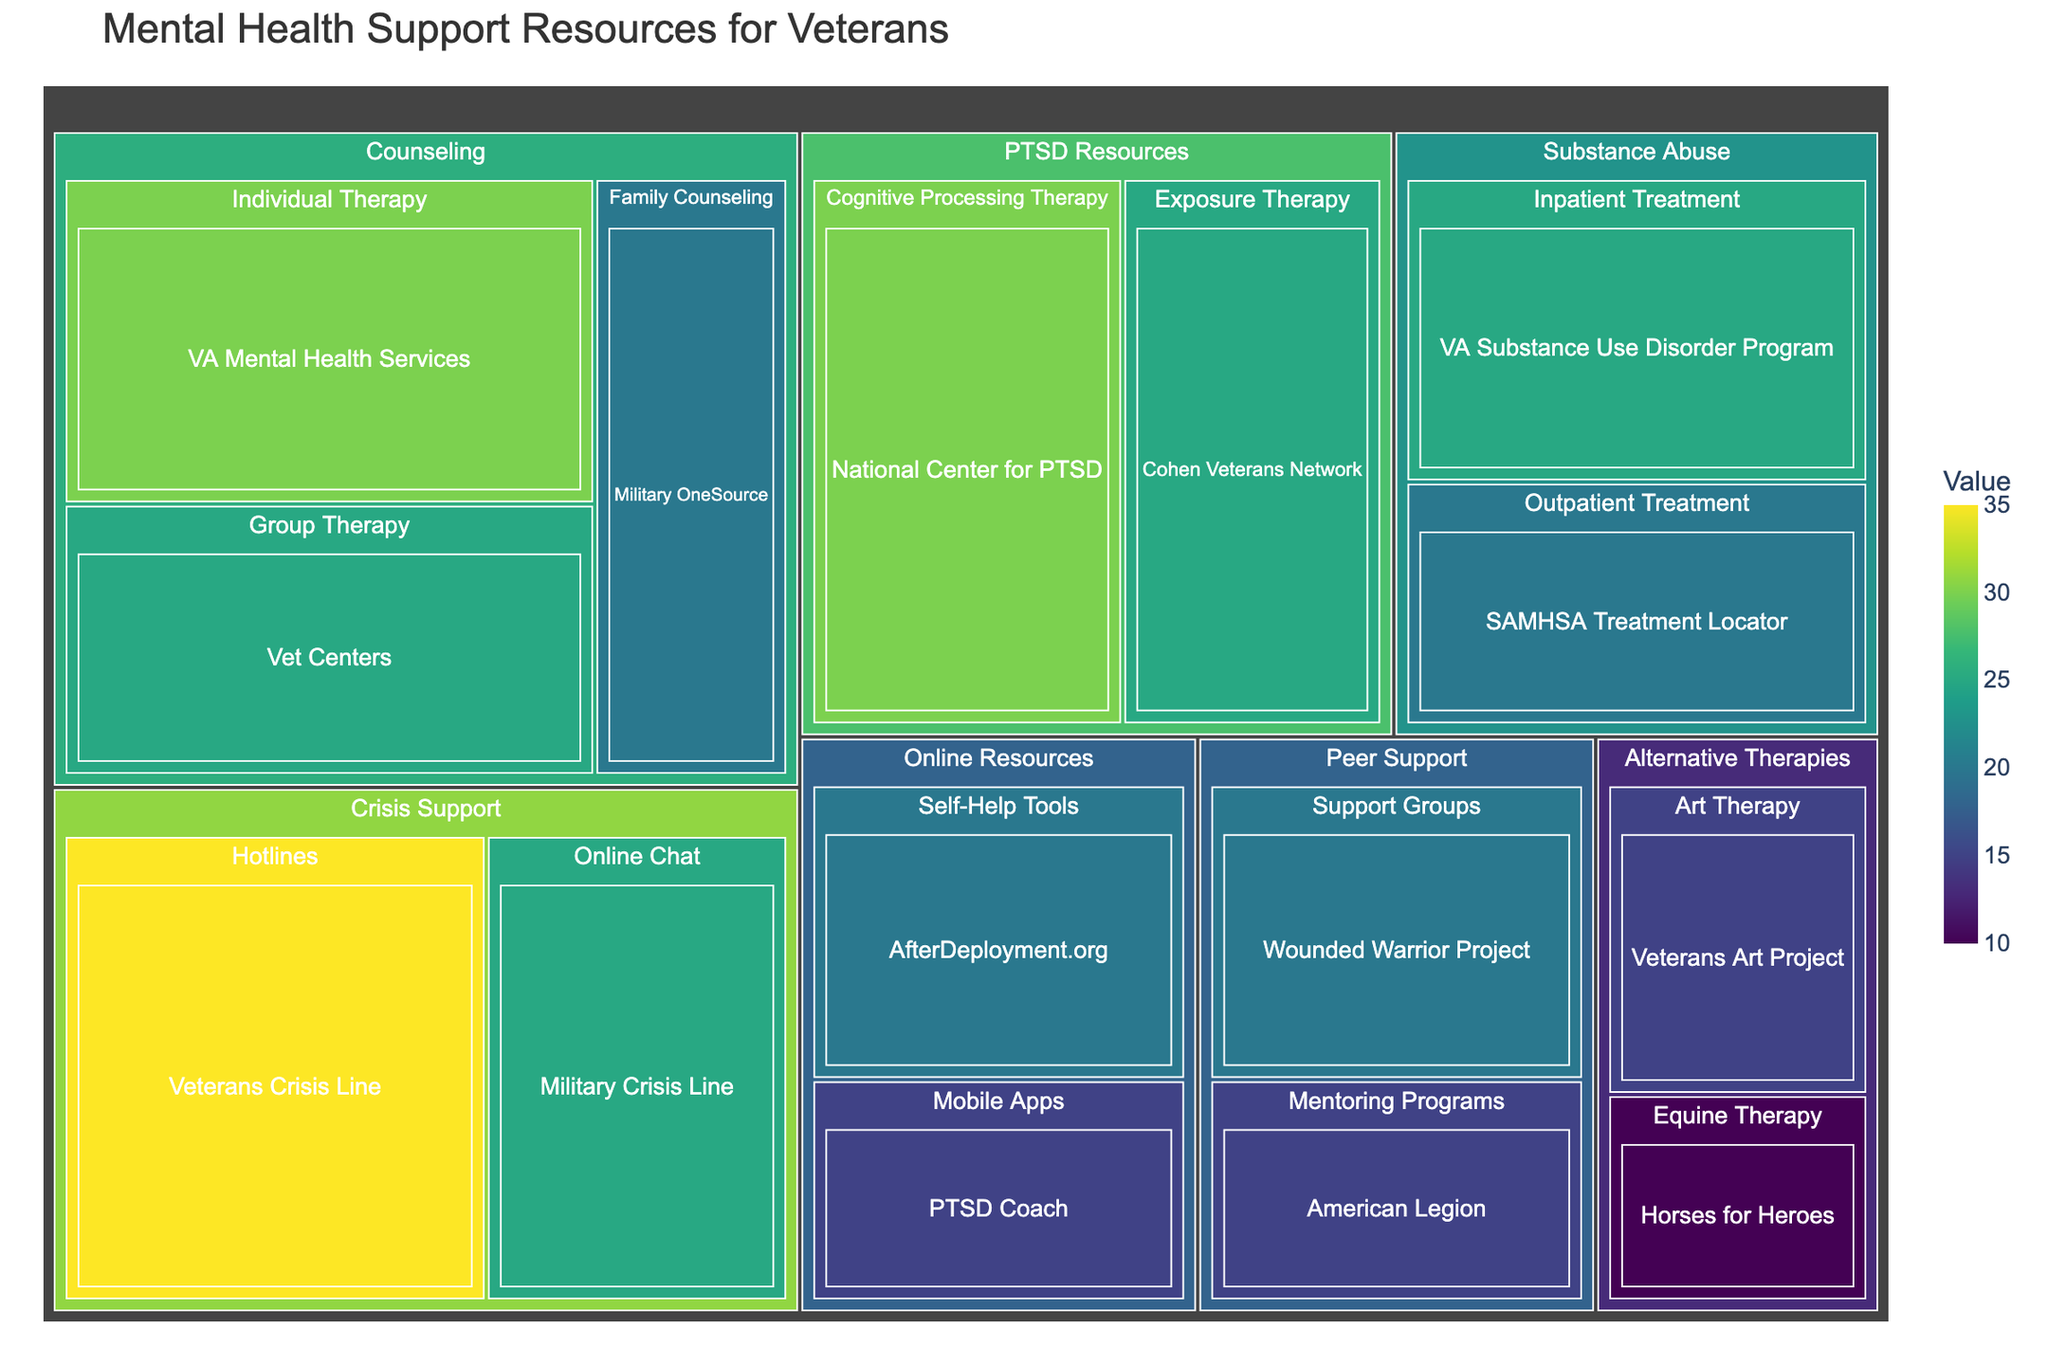what is the title of the treemap? The title can usually be found at the top of the figure. In this treemap, it is displayed prominently as a heading.
Answer: Mental Health Support Resources for Veterans Which category has the highest value? Each category is a distinct section of the treemap, distinguished by color. By comparing the values within each category, the one with the highest value can be identified. The category with the highest overall value in all its subcategories is "Counseling" with individual values adding up to 75.
Answer: Counseling What resource has the highest value within the Crisis Support category? Within each category, resources are divided into subcategories. By identifying the resource within the Crisis Support category, we see that "Veterans Crisis Line" has the highest value of 35.
Answer: Veterans Crisis Line What's the total value for Online Resources? By adding the values of "Self-Help Tools" (20) and "Mobile Apps" (15) within the Online Resources category, we get the total value. 20 + 15 = 35.
Answer: 35 Which subcategory in Substance Abuse has a higher value? By comparing the values within the subcategories of the Substance Abuse category, "Inpatient Treatment" has a value of 25, while "Outpatient Treatment" has a value of 20; hence "Inpatient Treatment" has a higher value.
Answer: Inpatient Treatment What is the average value of resources in the Peer Support category? The Peer Support category includes "Support Groups" (20) and "Mentoring Programs" (15). The average value is calculated by summing the values and dividing by the number of resources: (20 + 15) / 2 = 17.5.
Answer: 17.5 Which subcategory has the least value within the Alternative Therapies category? Looking at the values in the Alternative Therapies category, "Equine Therapy" has a value of 10, while "Art Therapy" has a value of 15. Thus, "Equine Therapy" has the least value.
Answer: Equine Therapy How does the value of VA Mental Health Services compare to the value of the Veterans Crisis Line? VA Mental Health Services has a value of 30, and the Veterans Crisis Line has a value of 35. By comparing them, we see that Veterans Crisis Line has a higher value.
Answer: Veterans Crisis Line What is the combined value of all resources within the Counseling category? Adding the values of individual resources within the Counseling category: VA Mental Health Services (30) + Vet Centers (25) + Military OneSource (20) = 75. This gives the combined total.
Answer: 75 